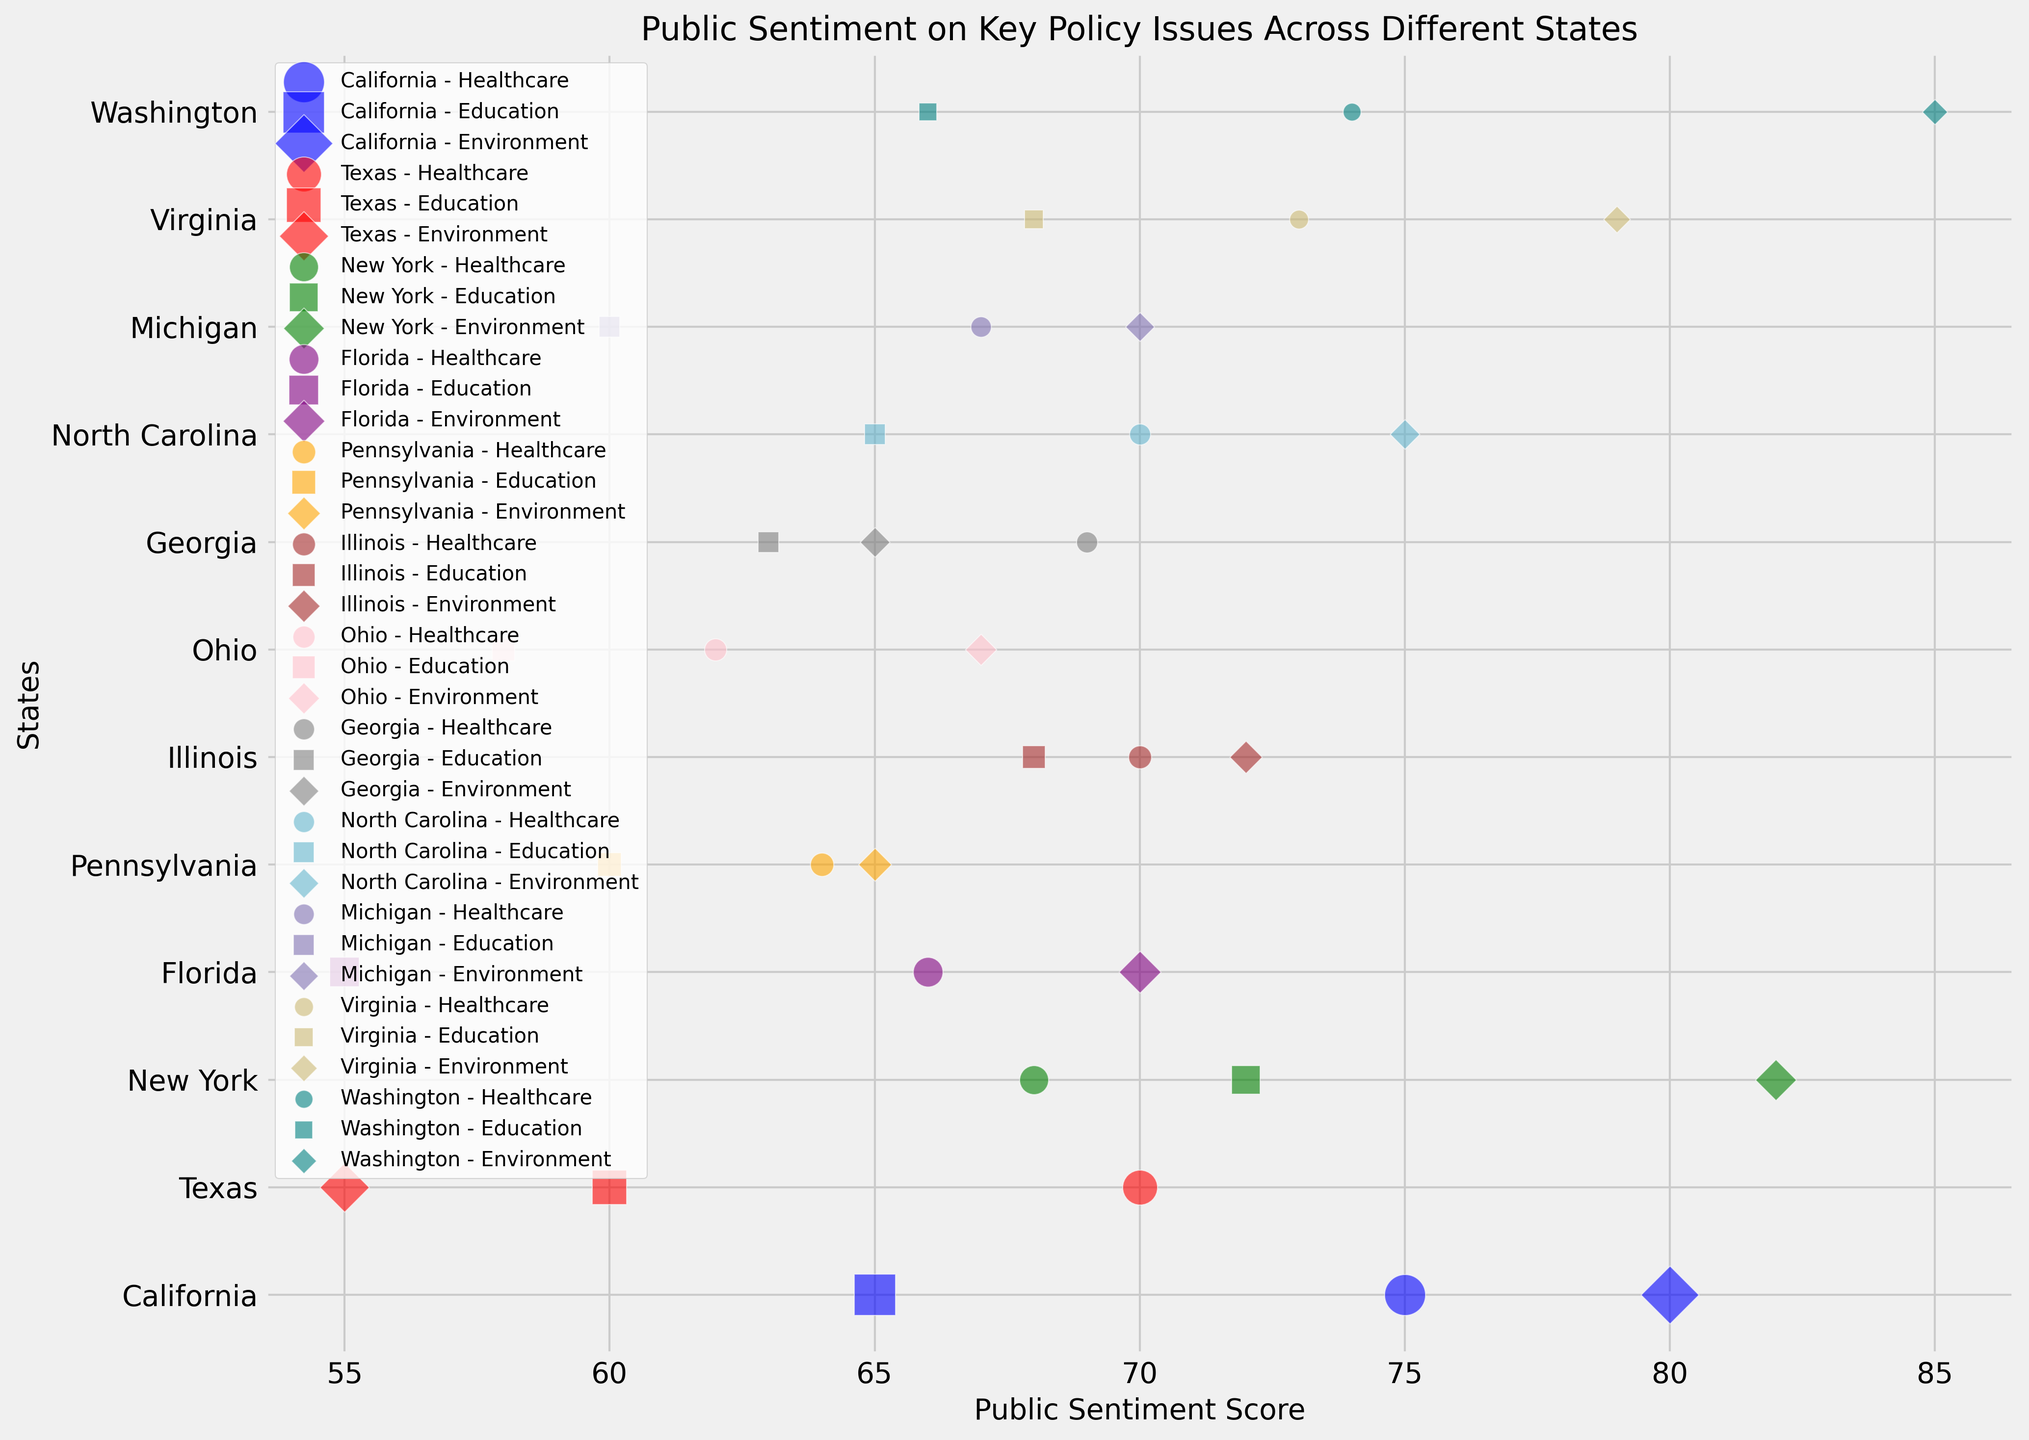Which state has the highest public sentiment score for Environment policy? The public sentiment scores for Environment policy are represented by different markers. By finding the highest position among these markers on the sentiment score axis, we see that Washington has the highest sentiment score of 85.
Answer: Washington Between Healthcare and Education policies in Texas, which has a higher public sentiment score? In Texas, the marker for Healthcare with a sentiment score is 70, and the marker for Education is 60. Comparing these, healthcare has a higher score.
Answer: Healthcare What is the average public sentiment score for Healthcare in California, Texas, and New York? The healthcare scores for California, Texas, and New York are 75, 70, and 68 respectively. Summing these scores, we get 213, then dividing by 3 gives 71 as the average public sentiment score for Healthcare in these states.
Answer: 71 Which state has the smallest population impact for Environment policy? Comparing the bubble sizes representing the Environment policy impact across states, Virginia has the smallest bubble size, indicating the least population impact. Virginia’s population impact for Environment is 8,500,000 people.
Answer: Virginia How does the public sentiment score for Education in Florida compare to that in Michigan? The public sentiment score for Education in Florida is represented by its marker at 55, whereas in Michigan the corresponding marker is at 60, so Michigan has a higher sentiment score for Education.
Answer: Michigan Is the public sentiment score for Environment policy higher in North Carolina or Pennsylvania? By comparing the sentiment scores, North Carolina has a public sentiment score of 75 for Environment policy, whereas Pennsylvania has a score of 65. North Carolina’s score is higher.
Answer: North Carolina What is the difference in the public sentiment score for Healthcare between Ohio and New York? Ohio’s public sentiment score for Healthcare is 62, and New York’s is 68. The difference between these scores is 68 - 62 = 6.
Answer: 6 Which state shows the highest public sentiment score for Education? By checking the markers for Education policy across states, we see that New York has the highest sentiment score at 72.
Answer: New York What is the combined population impact for the Environment policy in California, Texas, and New York? California’s impact is 40 million, Texas’s impact is 29 million, and New York’s impact is 20 million. The combined impact is 40 + 29 + 20 = 89 million people.
Answer: 89 million Comparing Illinois and Virginia, which state has a higher public sentiment score for Environment policy? The marker for Environment in Illinois indicates a score of 72, whereas Virginia's marker is at 79. Thus, Virginia has a higher public sentiment score for the Environment policy.
Answer: Virginia 